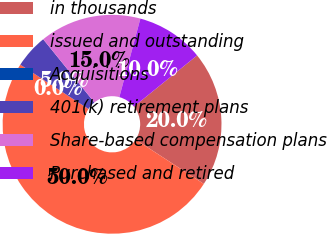<chart> <loc_0><loc_0><loc_500><loc_500><pie_chart><fcel>in thousands<fcel>issued and outstanding<fcel>Acquisitions<fcel>401(k) retirement plans<fcel>Share-based compensation plans<fcel>Purchased and retired<nl><fcel>20.0%<fcel>50.0%<fcel>0.0%<fcel>5.0%<fcel>15.0%<fcel>10.0%<nl></chart> 